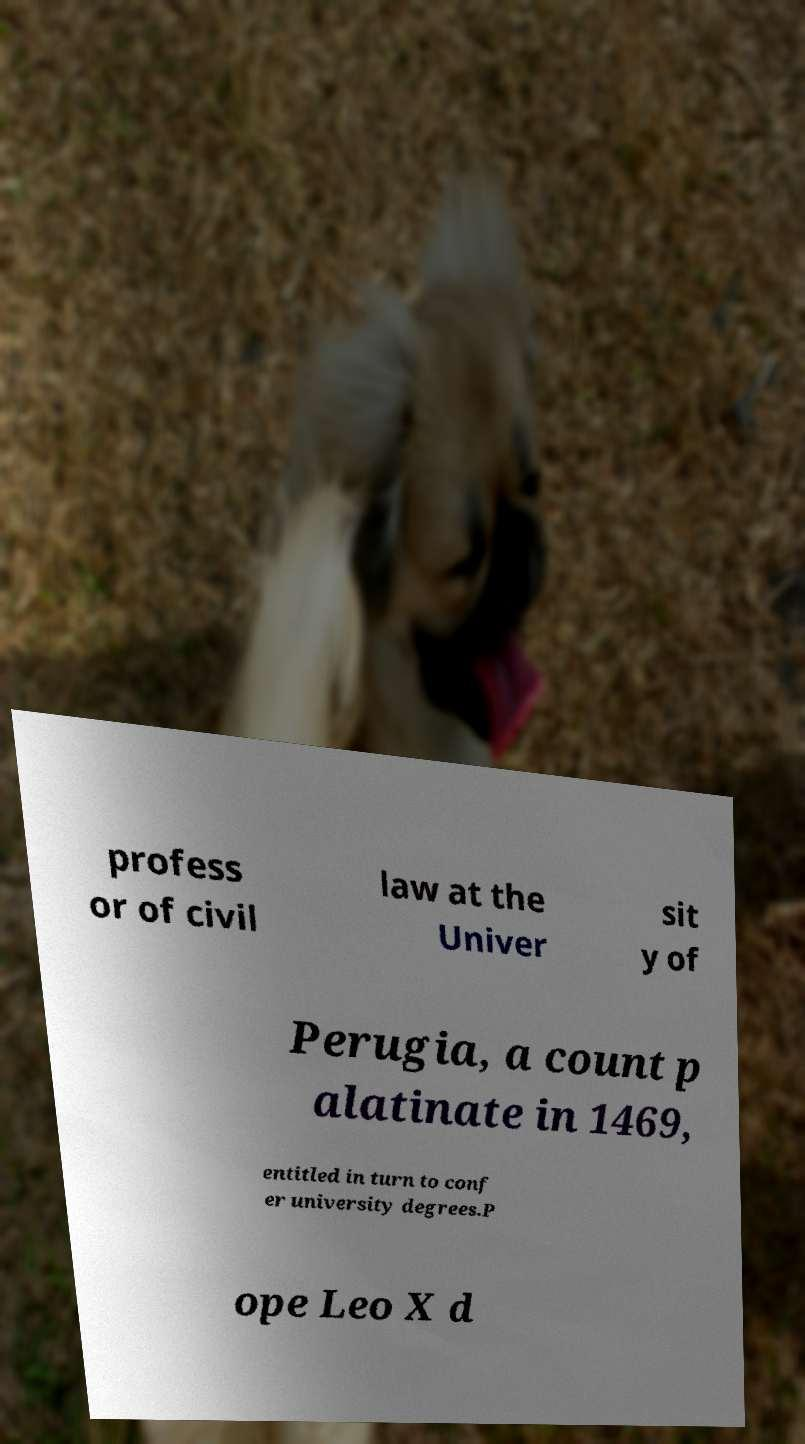Could you assist in decoding the text presented in this image and type it out clearly? profess or of civil law at the Univer sit y of Perugia, a count p alatinate in 1469, entitled in turn to conf er university degrees.P ope Leo X d 